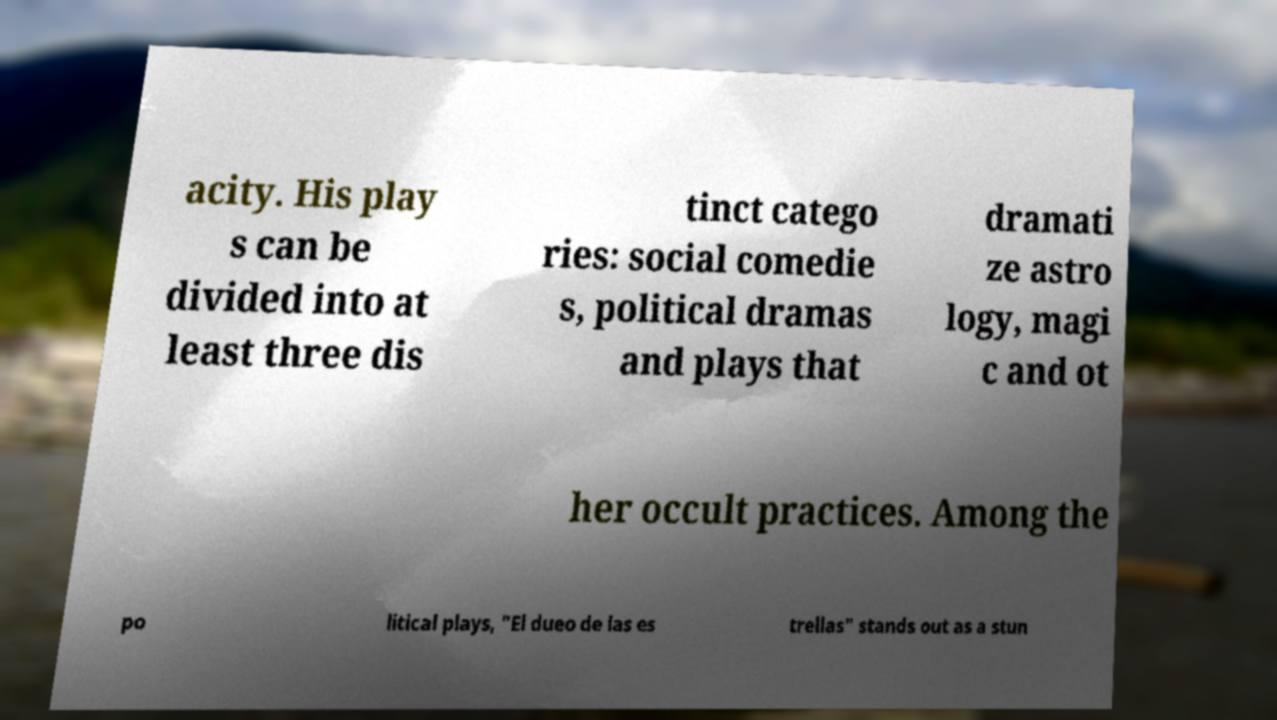For documentation purposes, I need the text within this image transcribed. Could you provide that? acity. His play s can be divided into at least three dis tinct catego ries: social comedie s, political dramas and plays that dramati ze astro logy, magi c and ot her occult practices. Among the po litical plays, "El dueo de las es trellas" stands out as a stun 